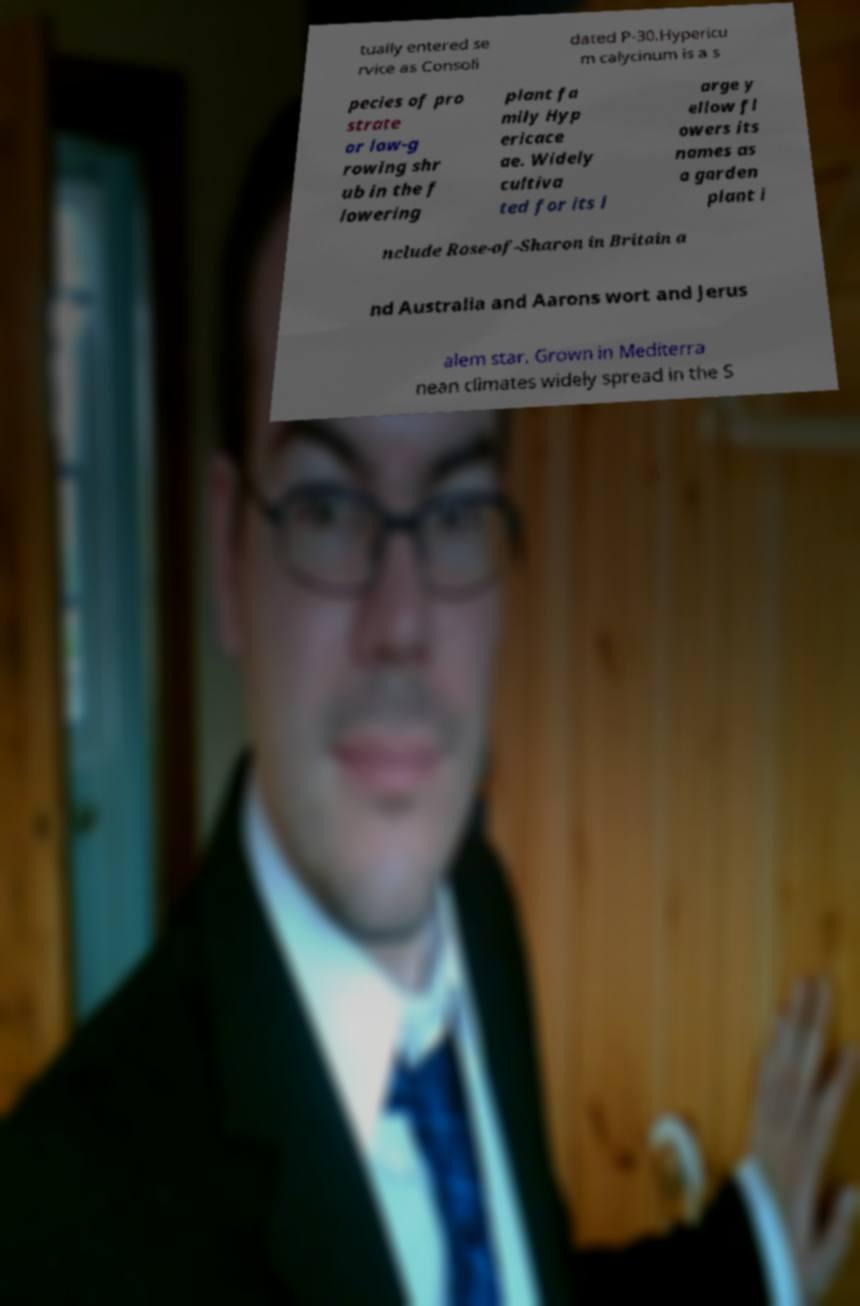What messages or text are displayed in this image? I need them in a readable, typed format. tually entered se rvice as Consoli dated P-30.Hypericu m calycinum is a s pecies of pro strate or low-g rowing shr ub in the f lowering plant fa mily Hyp ericace ae. Widely cultiva ted for its l arge y ellow fl owers its names as a garden plant i nclude Rose-of-Sharon in Britain a nd Australia and Aarons wort and Jerus alem star. Grown in Mediterra nean climates widely spread in the S 